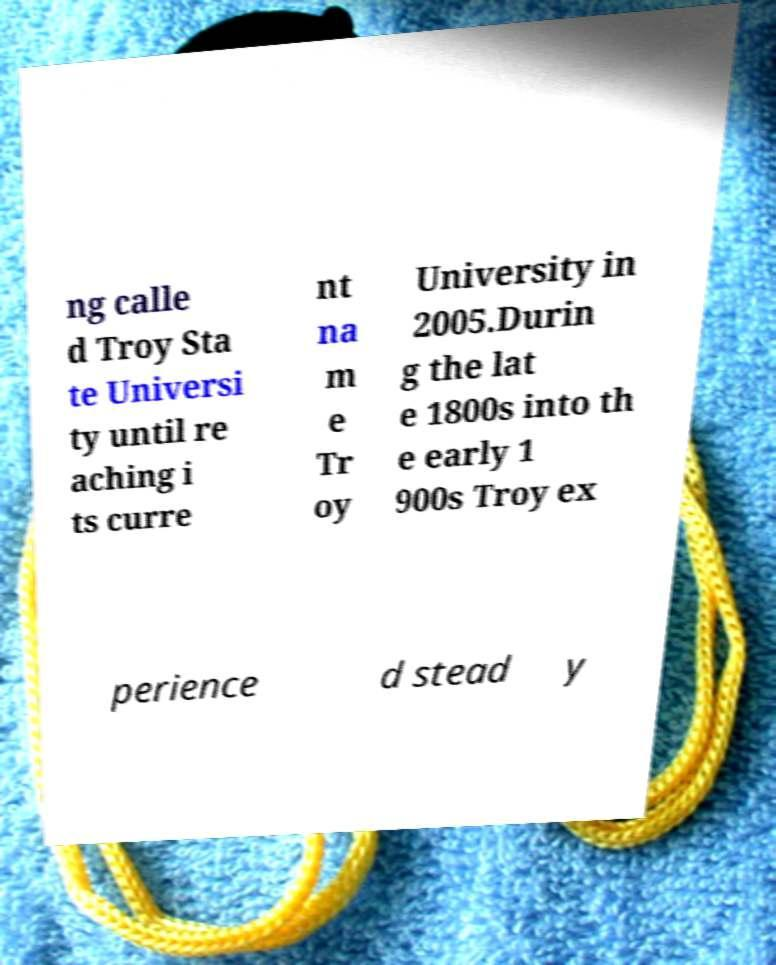What messages or text are displayed in this image? I need them in a readable, typed format. ng calle d Troy Sta te Universi ty until re aching i ts curre nt na m e Tr oy University in 2005.Durin g the lat e 1800s into th e early 1 900s Troy ex perience d stead y 